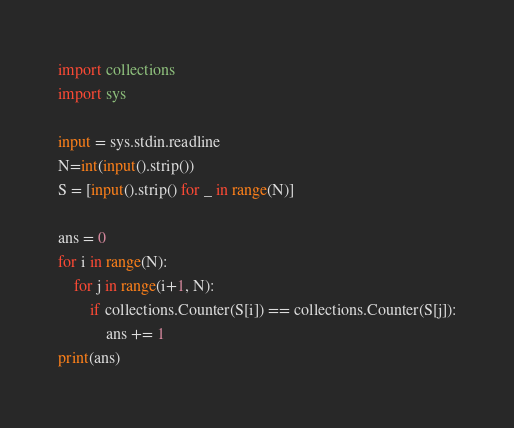Convert code to text. <code><loc_0><loc_0><loc_500><loc_500><_Python_>import collections
import sys

input = sys.stdin.readline
N=int(input().strip())
S = [input().strip() for _ in range(N)]

ans = 0
for i in range(N):
    for j in range(i+1, N):
        if collections.Counter(S[i]) == collections.Counter(S[j]):
            ans += 1
print(ans)
</code> 